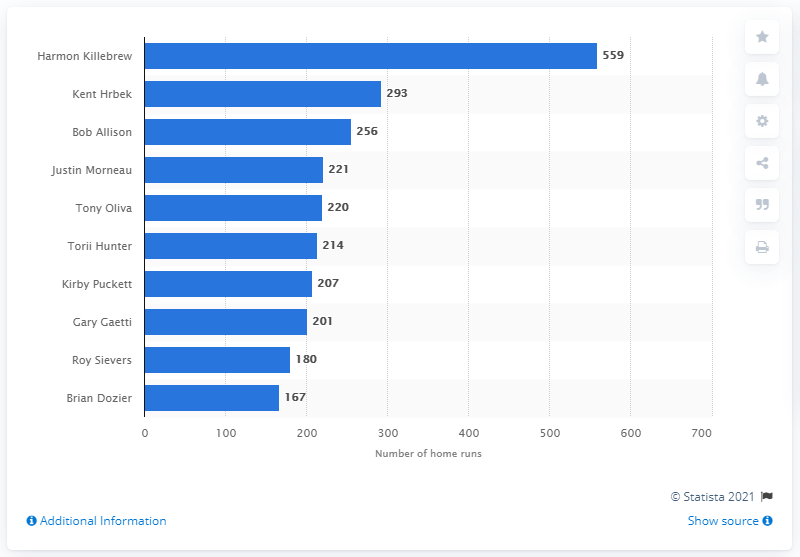Draw attention to some important aspects in this diagram. Harmon Killebrew has hit a total of 559 home runs. 